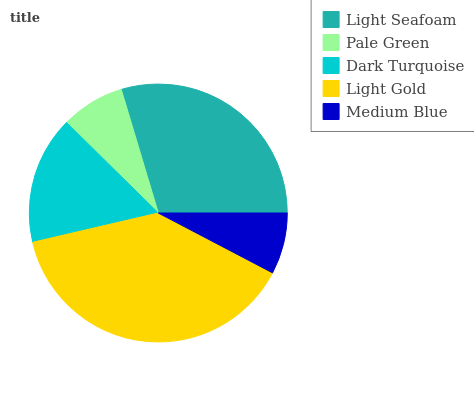Is Medium Blue the minimum?
Answer yes or no. Yes. Is Light Gold the maximum?
Answer yes or no. Yes. Is Pale Green the minimum?
Answer yes or no. No. Is Pale Green the maximum?
Answer yes or no. No. Is Light Seafoam greater than Pale Green?
Answer yes or no. Yes. Is Pale Green less than Light Seafoam?
Answer yes or no. Yes. Is Pale Green greater than Light Seafoam?
Answer yes or no. No. Is Light Seafoam less than Pale Green?
Answer yes or no. No. Is Dark Turquoise the high median?
Answer yes or no. Yes. Is Dark Turquoise the low median?
Answer yes or no. Yes. Is Light Seafoam the high median?
Answer yes or no. No. Is Medium Blue the low median?
Answer yes or no. No. 